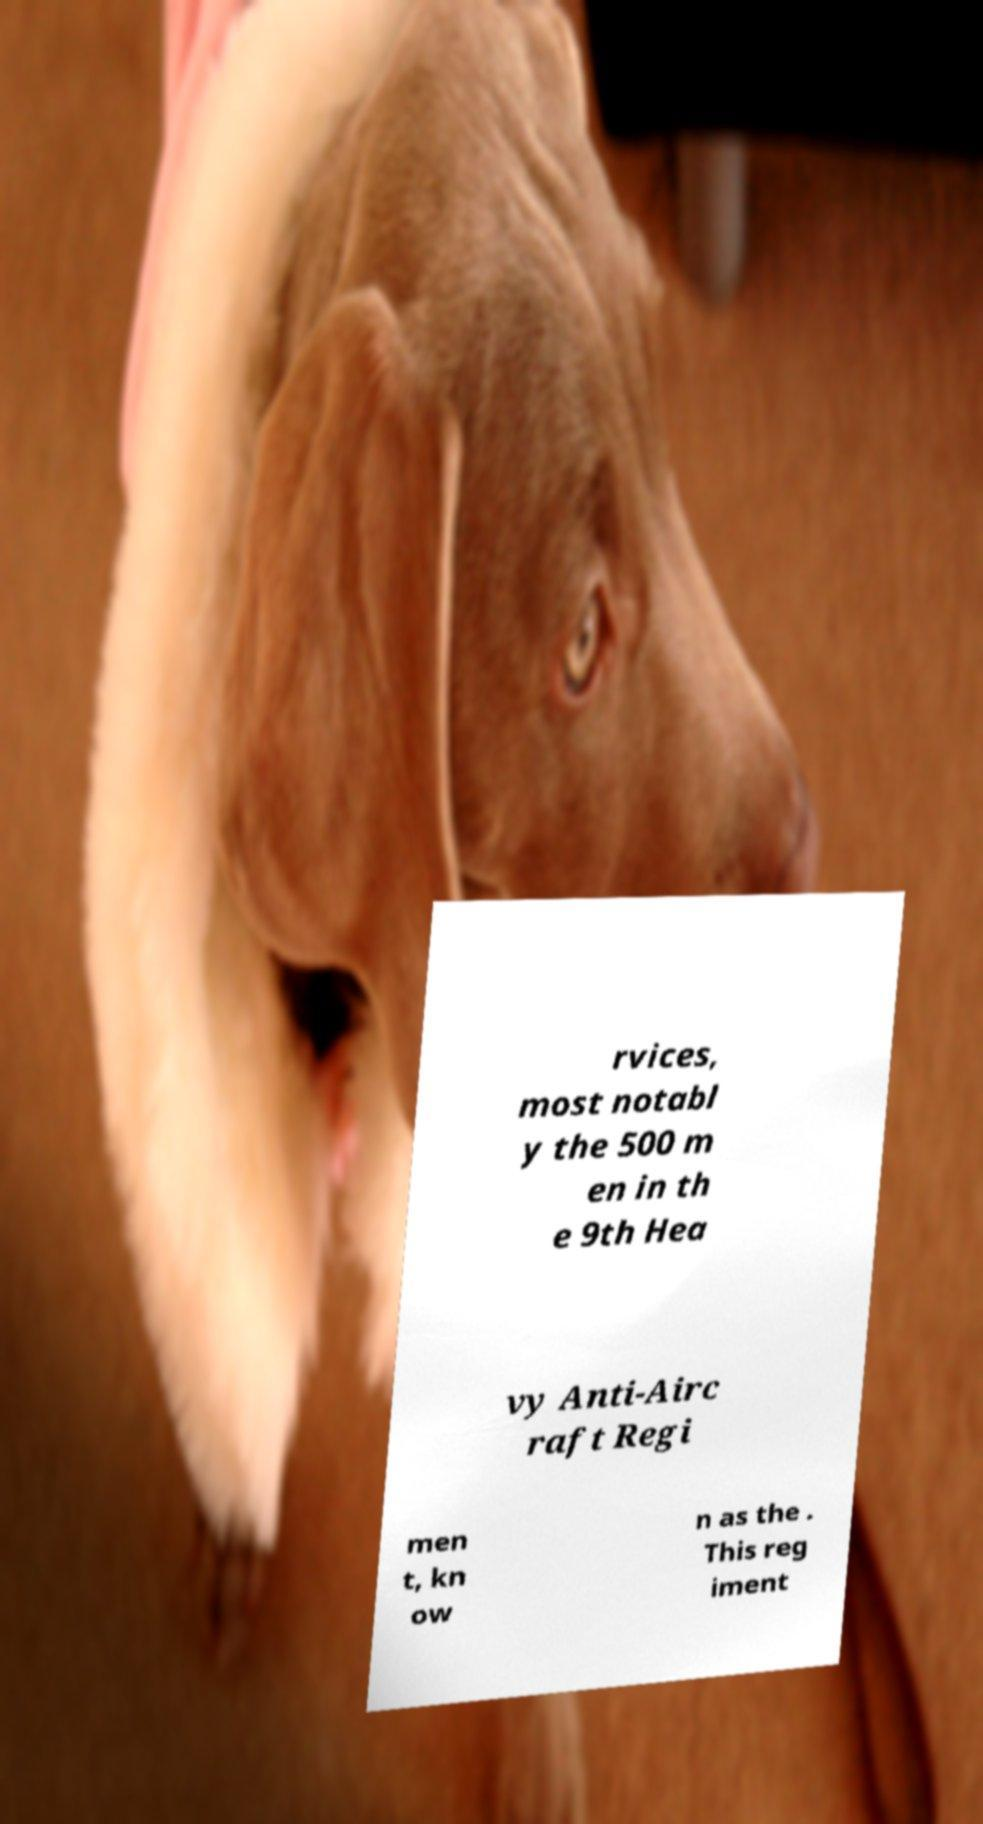For documentation purposes, I need the text within this image transcribed. Could you provide that? rvices, most notabl y the 500 m en in th e 9th Hea vy Anti-Airc raft Regi men t, kn ow n as the . This reg iment 